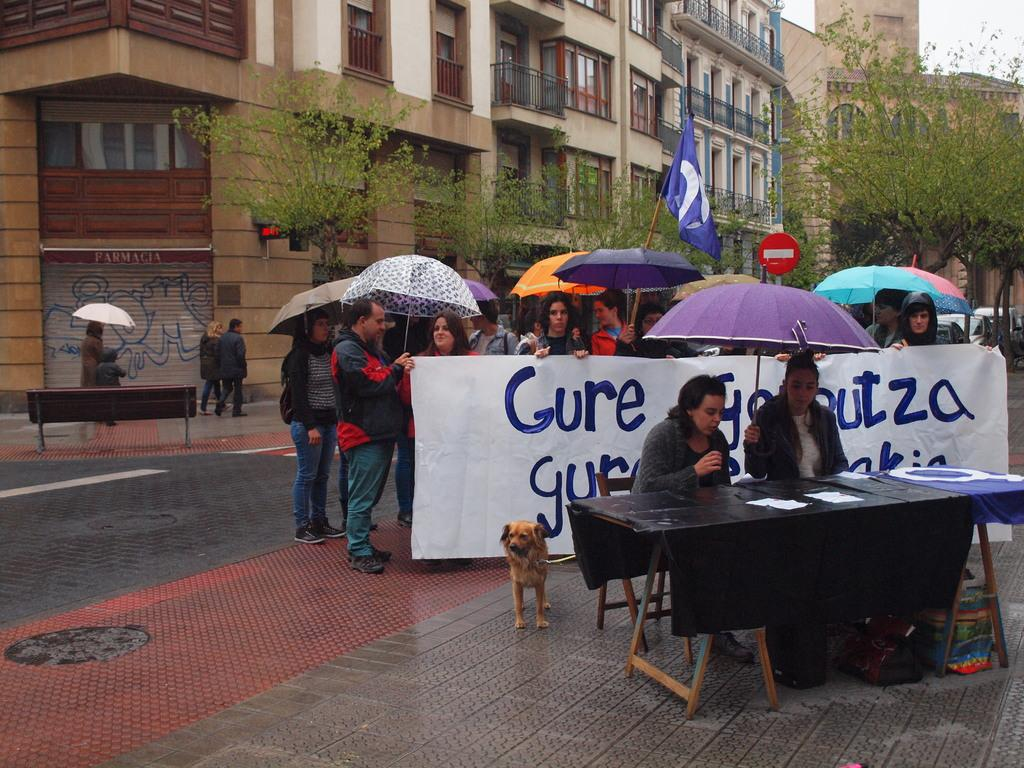How many people are in the image? There is a group of people in the image. Where are the people located in the image? The people are standing on the road. What are the people holding in the image? The people are holding an umbrella. What type of vegetation can be seen in the image? There are trees in the image. What type of structure is visible in the image? There is a building in the image. Are there any animals present in the image? Yes, there is a dog in the image. What type of veil is draped over the cow in the image? There is no cow or veil present in the image. What date is marked on the calendar in the image? There is no calendar present in the image. 